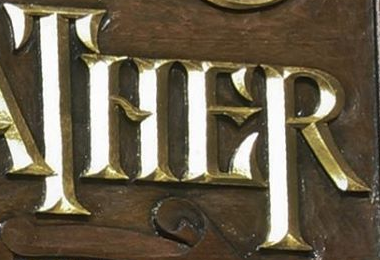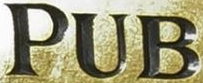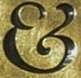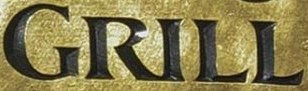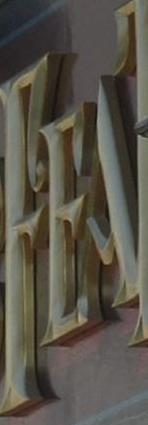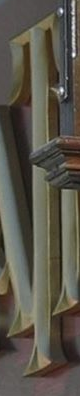Identify the words shown in these images in order, separated by a semicolon. THER; PUB; &; GRILL; FEA; T 